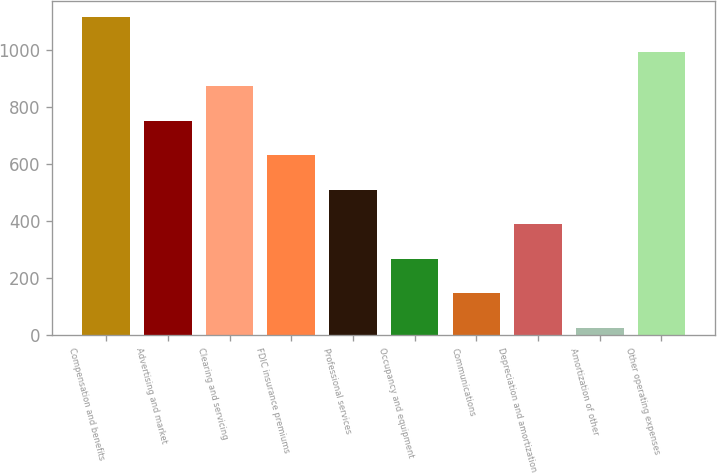<chart> <loc_0><loc_0><loc_500><loc_500><bar_chart><fcel>Compensation and benefits<fcel>Advertising and market<fcel>Clearing and servicing<fcel>FDIC insurance premiums<fcel>Professional services<fcel>Occupancy and equipment<fcel>Communications<fcel>Depreciation and amortization<fcel>Amortization of other<fcel>Other operating expenses<nl><fcel>1114.03<fcel>751.42<fcel>872.29<fcel>630.55<fcel>509.68<fcel>267.94<fcel>147.07<fcel>388.81<fcel>26.2<fcel>993.16<nl></chart> 